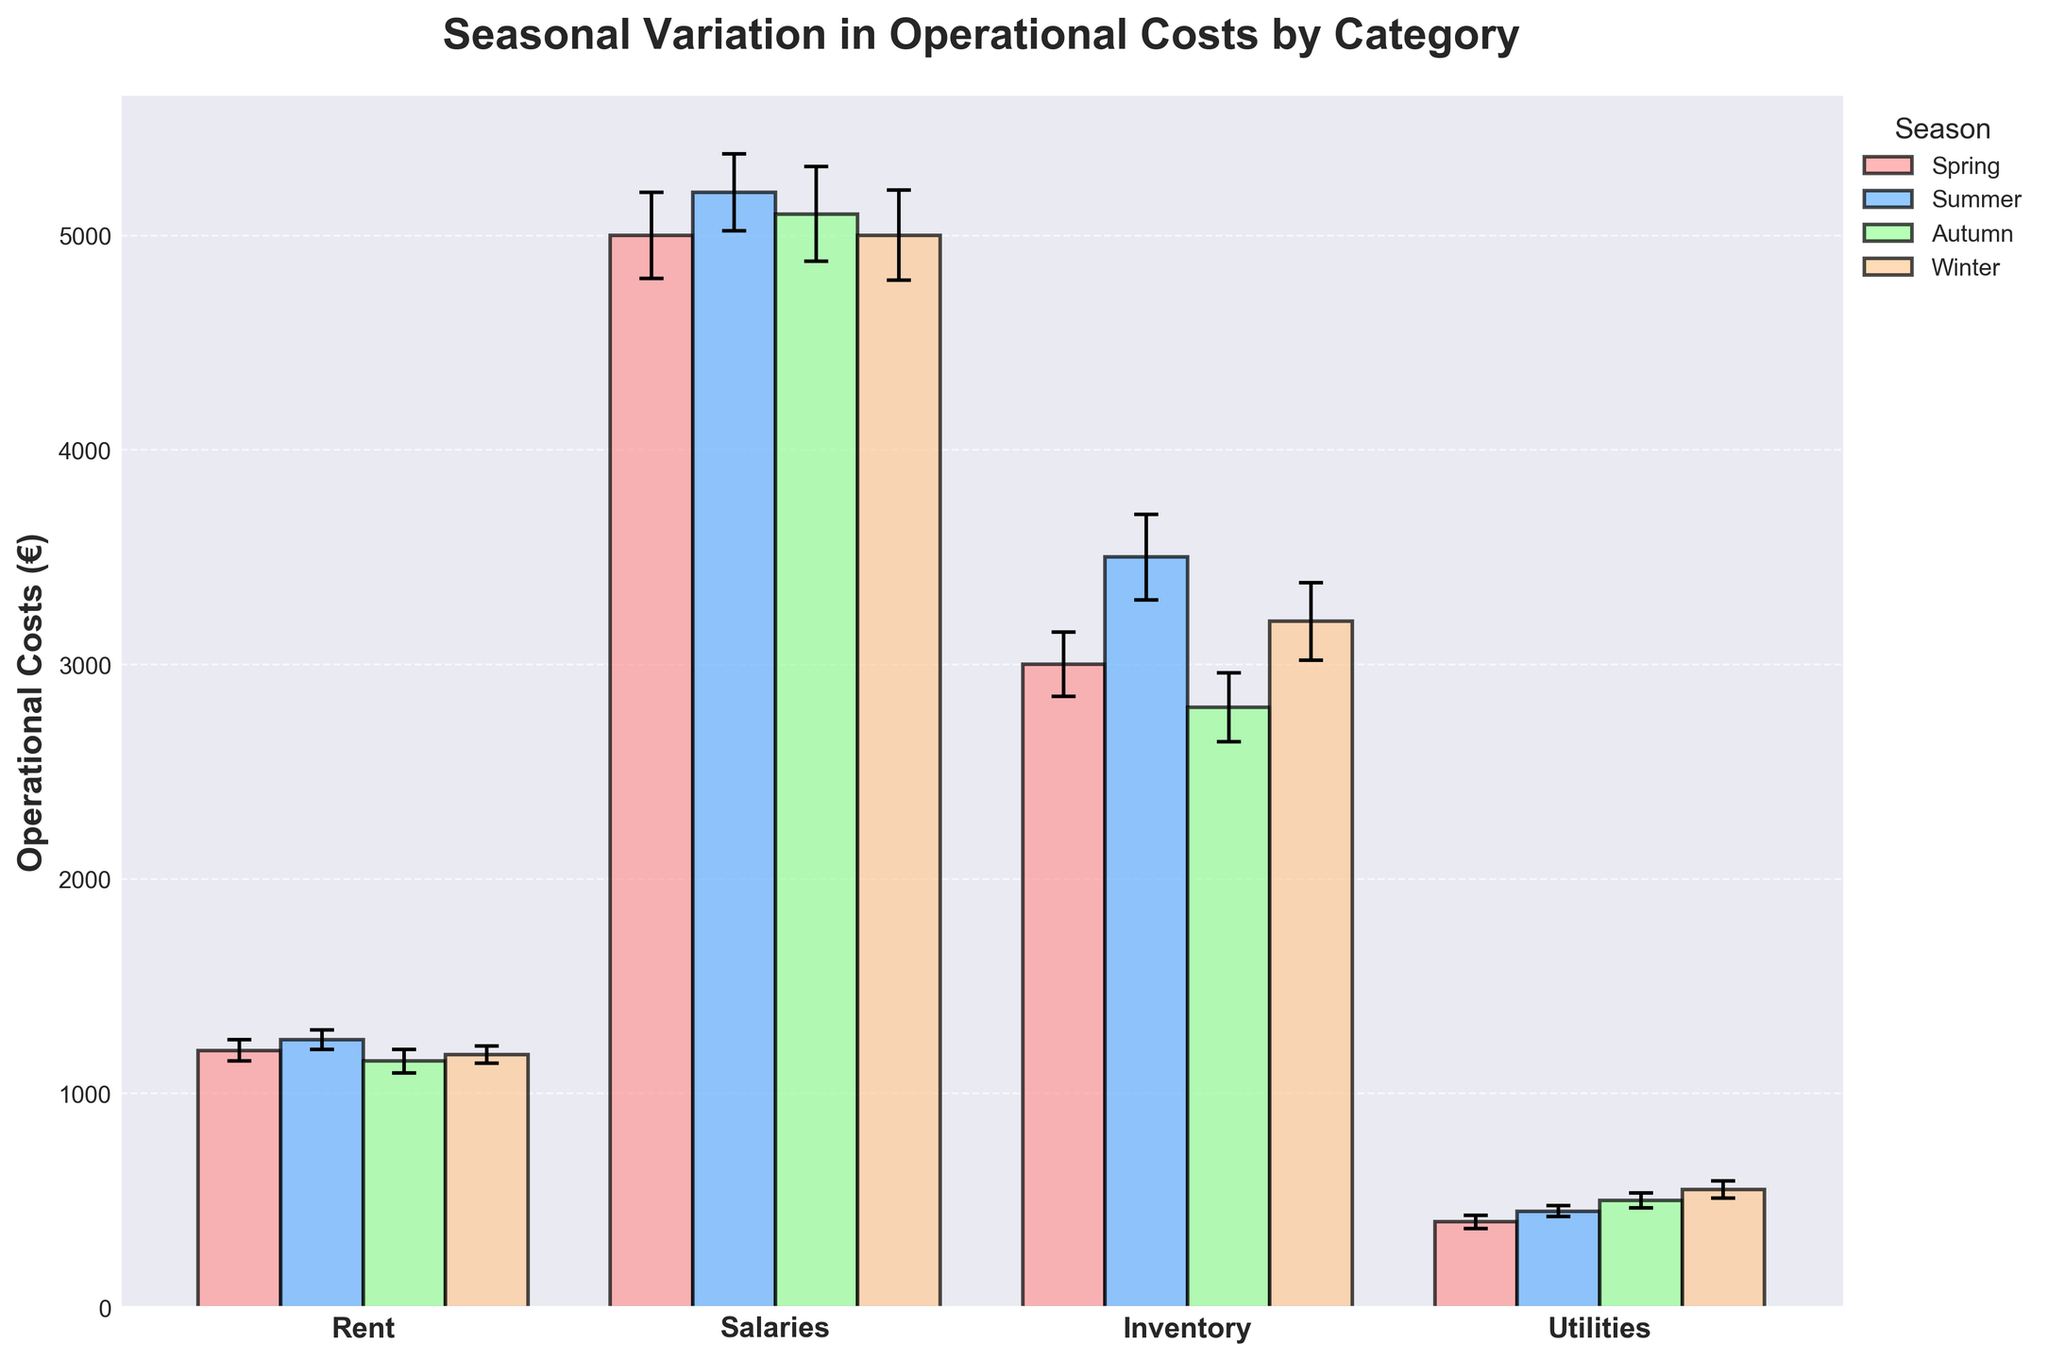What is the title of the chart? The title is usually located at the top of the chart; in this case, it reads "Seasonal Variation in Operational Costs by Category."
Answer: Seasonal Variation in Operational Costs by Category What are the four main categories shown on the x-axis? The x-axis labels represent the categories: Rent, Salaries, Inventory, and Utilities.
Answer: Rent, Salaries, Inventory, Utilities In which season are the salaries the highest? Look for the tallest bar under the "Salaries" category across all seasons. The highest bar corresponds to Summer.
Answer: Summer What is the mean operational cost for Inventory in Winter? Locate the bar for Inventory in Winter and read the mean cost. The value is 3200 euros.
Answer: 3200 euros Which category shows the most significant seasonal variation in costs? To determine this, observe which category's bars have the greatest vertical spread. Inventory has the most significant variation, ranging from 2800 to 3500 euros.
Answer: Inventory What is the error margin for Utilities in Autumn? Find the bar for Utilities in Autumn and note the error bars. The error margin is 35 euros.
Answer: 35 euros How much more is the mean cost of Utilities in Winter compared to Spring? Compare the bar heights for Utilities in Winter and Spring and subtract the Spring mean cost from the Winter mean cost: 550 - 400 = 150 euros.
Answer: 150 euros Which season has the highest overall operational cost across all categories? Compare the sum of mean costs for each season: Spring (5000+3000+1200+400 = 9600), Summer (5200+3500+1250+450 = 10400), Autumn (5100+2800+1150+500 = 9550), Winter (5000+3200+1180+550 = 9930). Summer has the highest overall cost.
Answer: Summer What is the sum of mean operational costs for Rent across all seasons? Add the mean costs of Rent for each season: 1200 (Spring) + 1250 (Summer) + 1150 (Autumn) + 1180 (Winter) = 4780 euros.
Answer: 4780 euros Which category has the smallest error margin in Summer? Identify the smallest error bar length for categories in Summer. Rent has the smallest error margin of 45 euros.
Answer: Rent 